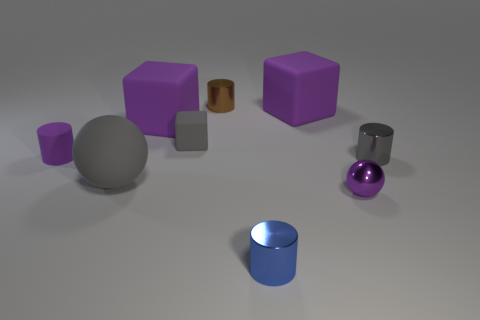Add 1 blue metal spheres. How many objects exist? 10 Subtract all cylinders. How many objects are left? 5 Add 9 small gray cylinders. How many small gray cylinders exist? 10 Subtract 0 green blocks. How many objects are left? 9 Subtract all tiny gray cylinders. Subtract all purple matte cubes. How many objects are left? 6 Add 6 small metallic cylinders. How many small metallic cylinders are left? 9 